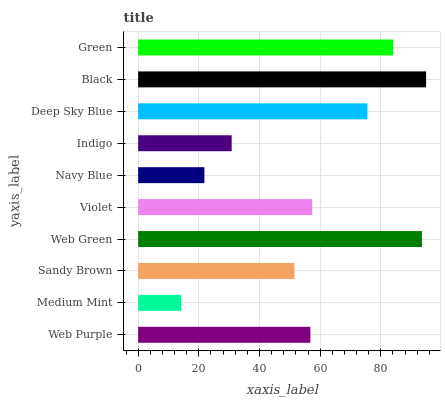Is Medium Mint the minimum?
Answer yes or no. Yes. Is Black the maximum?
Answer yes or no. Yes. Is Sandy Brown the minimum?
Answer yes or no. No. Is Sandy Brown the maximum?
Answer yes or no. No. Is Sandy Brown greater than Medium Mint?
Answer yes or no. Yes. Is Medium Mint less than Sandy Brown?
Answer yes or no. Yes. Is Medium Mint greater than Sandy Brown?
Answer yes or no. No. Is Sandy Brown less than Medium Mint?
Answer yes or no. No. Is Violet the high median?
Answer yes or no. Yes. Is Web Purple the low median?
Answer yes or no. Yes. Is Deep Sky Blue the high median?
Answer yes or no. No. Is Navy Blue the low median?
Answer yes or no. No. 